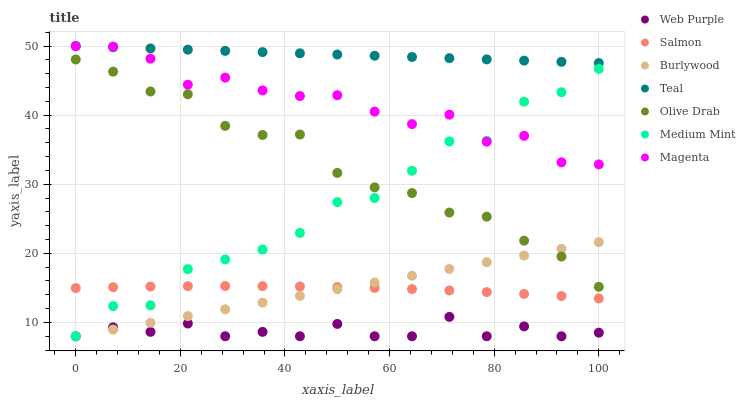Does Web Purple have the minimum area under the curve?
Answer yes or no. Yes. Does Teal have the maximum area under the curve?
Answer yes or no. Yes. Does Burlywood have the minimum area under the curve?
Answer yes or no. No. Does Burlywood have the maximum area under the curve?
Answer yes or no. No. Is Burlywood the smoothest?
Answer yes or no. Yes. Is Medium Mint the roughest?
Answer yes or no. Yes. Is Salmon the smoothest?
Answer yes or no. No. Is Salmon the roughest?
Answer yes or no. No. Does Medium Mint have the lowest value?
Answer yes or no. Yes. Does Salmon have the lowest value?
Answer yes or no. No. Does Magenta have the highest value?
Answer yes or no. Yes. Does Burlywood have the highest value?
Answer yes or no. No. Is Web Purple less than Teal?
Answer yes or no. Yes. Is Magenta greater than Olive Drab?
Answer yes or no. Yes. Does Medium Mint intersect Salmon?
Answer yes or no. Yes. Is Medium Mint less than Salmon?
Answer yes or no. No. Is Medium Mint greater than Salmon?
Answer yes or no. No. Does Web Purple intersect Teal?
Answer yes or no. No. 